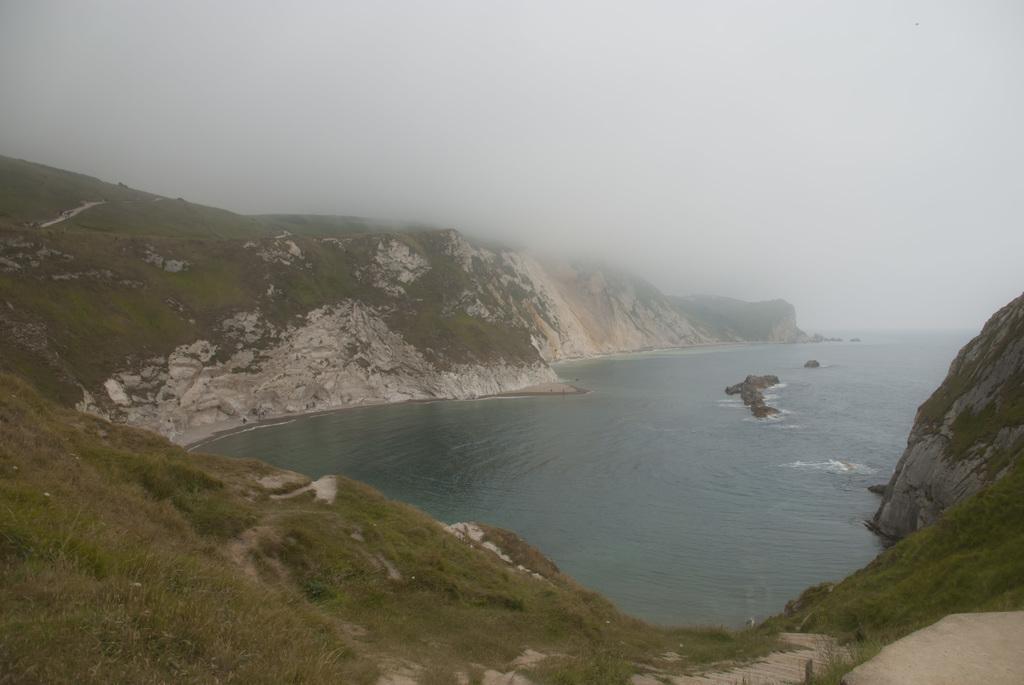How would you summarize this image in a sentence or two? This image is taken outdoors. At the top of the image there is a sky. At the bottom of the image there is a ground with grass on it. In the middle of the image there is a sea and there are a few hills. 